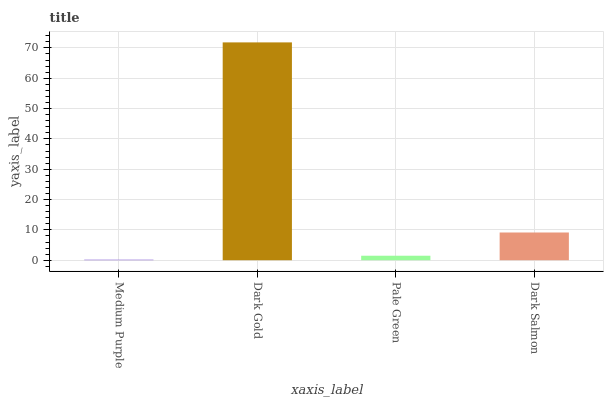Is Medium Purple the minimum?
Answer yes or no. Yes. Is Dark Gold the maximum?
Answer yes or no. Yes. Is Pale Green the minimum?
Answer yes or no. No. Is Pale Green the maximum?
Answer yes or no. No. Is Dark Gold greater than Pale Green?
Answer yes or no. Yes. Is Pale Green less than Dark Gold?
Answer yes or no. Yes. Is Pale Green greater than Dark Gold?
Answer yes or no. No. Is Dark Gold less than Pale Green?
Answer yes or no. No. Is Dark Salmon the high median?
Answer yes or no. Yes. Is Pale Green the low median?
Answer yes or no. Yes. Is Medium Purple the high median?
Answer yes or no. No. Is Dark Gold the low median?
Answer yes or no. No. 